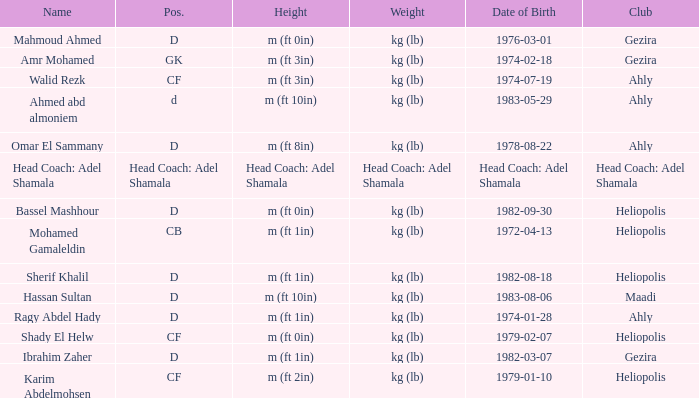What is Date of Birth, when Height is "Head Coach: Adel Shamala"? Head Coach: Adel Shamala. 